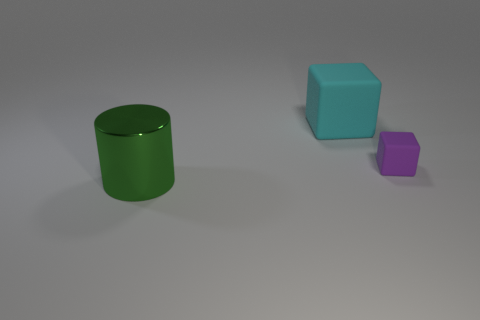Are the large thing that is on the right side of the big shiny cylinder and the block in front of the cyan block made of the same material?
Your response must be concise. Yes. Is the number of cyan rubber blocks greater than the number of blue spheres?
Your answer should be very brief. Yes. There is a rubber block to the left of the cube that is in front of the big thing on the right side of the large green metal cylinder; what color is it?
Make the answer very short. Cyan. There is a rubber block in front of the big cyan matte thing; is its color the same as the thing left of the large cube?
Make the answer very short. No. There is a block that is right of the big rubber cube; what number of cylinders are on the right side of it?
Keep it short and to the point. 0. Is there a cube?
Your answer should be compact. Yes. Are there fewer green things than small brown rubber balls?
Offer a terse response. No. What is the shape of the big object that is in front of the block behind the purple block?
Your answer should be compact. Cylinder. Are there any small matte cubes on the left side of the big cyan rubber block?
Offer a terse response. No. There is a block that is the same size as the metallic object; what is its color?
Ensure brevity in your answer.  Cyan. 